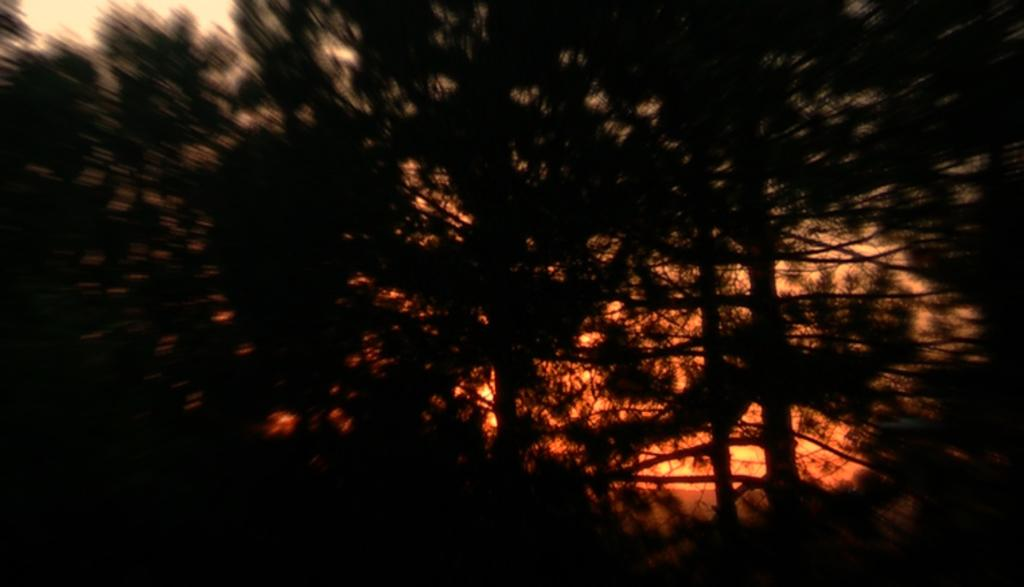What type of vegetation can be seen in the image? There are trees in the image. How would you describe the clarity of the image? The image is blurry. What color is present in the background of the image? There is an orange color in the background of the image. Where is the maid located in the image? There is no maid present in the image. What type of prison can be seen in the image? There is no prison present in the image. 